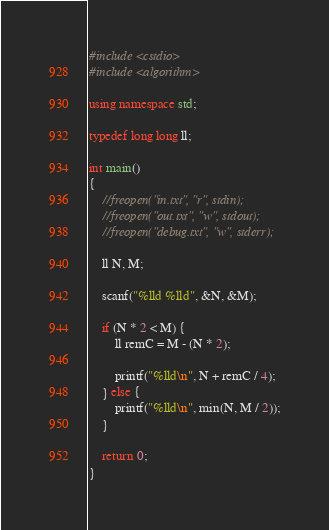<code> <loc_0><loc_0><loc_500><loc_500><_C++_>#include <cstdio>
#include <algorithm>

using namespace std;

typedef long long ll;

int main()
{
    //freopen("in.txt", "r", stdin);
    //freopen("out.txt", "w", stdout);
    //freopen("debug.txt", "w", stderr);

    ll N, M;

    scanf("%lld %lld", &N, &M);

    if (N * 2 < M) {
        ll remC = M - (N * 2);

        printf("%lld\n", N + remC / 4);
    } else {
        printf("%lld\n", min(N, M / 2));
    }

    return 0;
}
</code> 